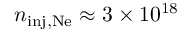<formula> <loc_0><loc_0><loc_500><loc_500>n _ { i n j , N e } \approx 3 \times 1 0 ^ { 1 8 }</formula> 